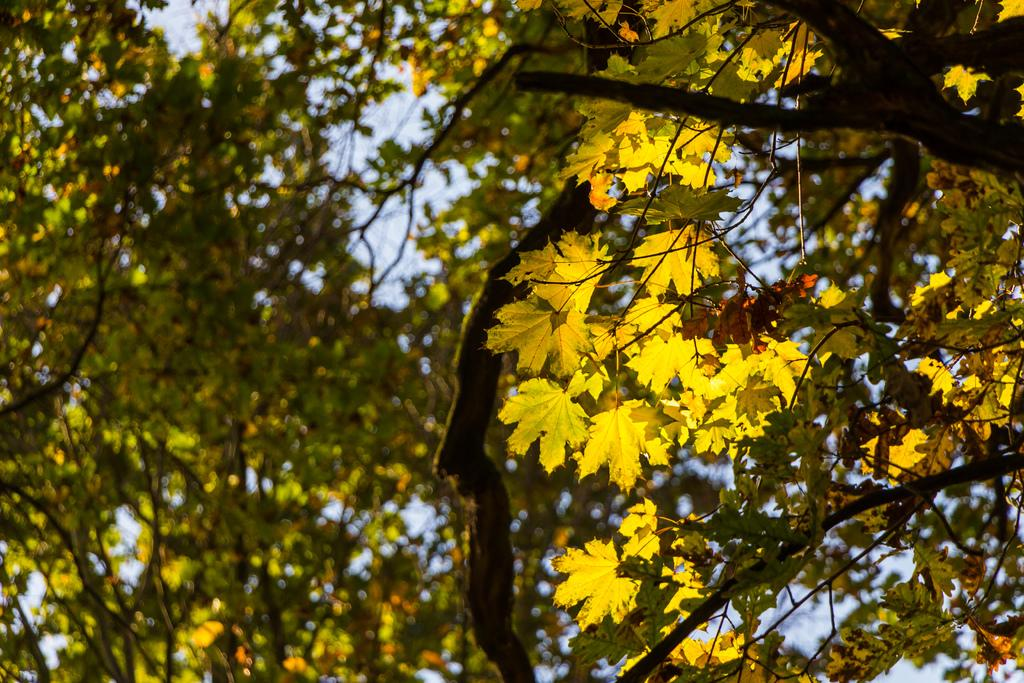What type of natural vegetation can be seen in the image? There are trees in the image. What type of music is the band playing in the image? There is no band present in the image, so it is not possible to determine what type of music they might be playing. 